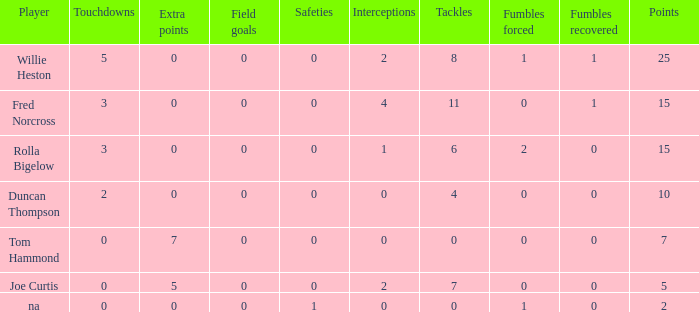How many Touchdowns have a Player of rolla bigelow, and an Extra points smaller than 0? None. 